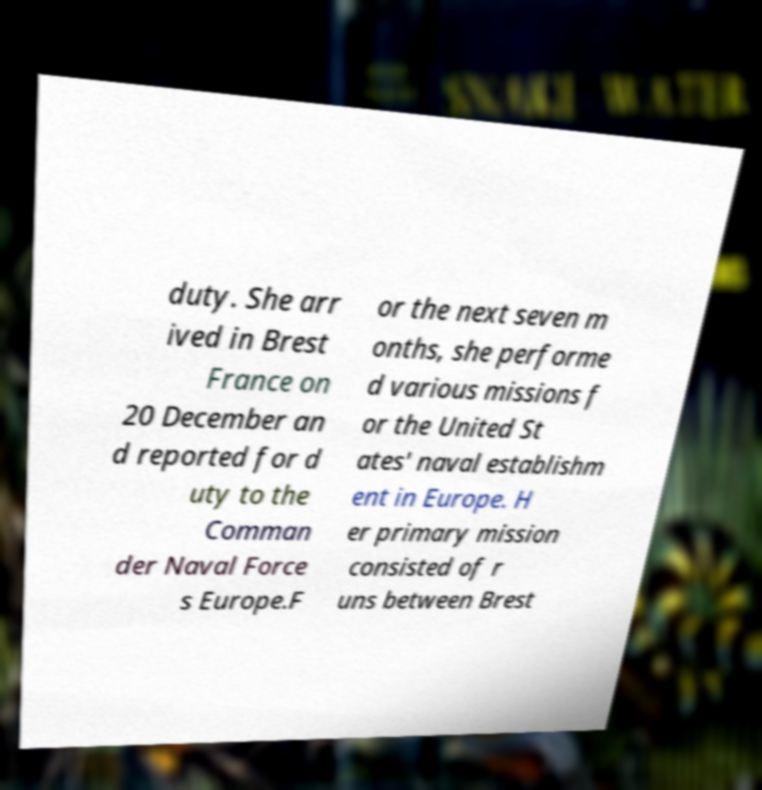Could you extract and type out the text from this image? duty. She arr ived in Brest France on 20 December an d reported for d uty to the Comman der Naval Force s Europe.F or the next seven m onths, she performe d various missions f or the United St ates' naval establishm ent in Europe. H er primary mission consisted of r uns between Brest 